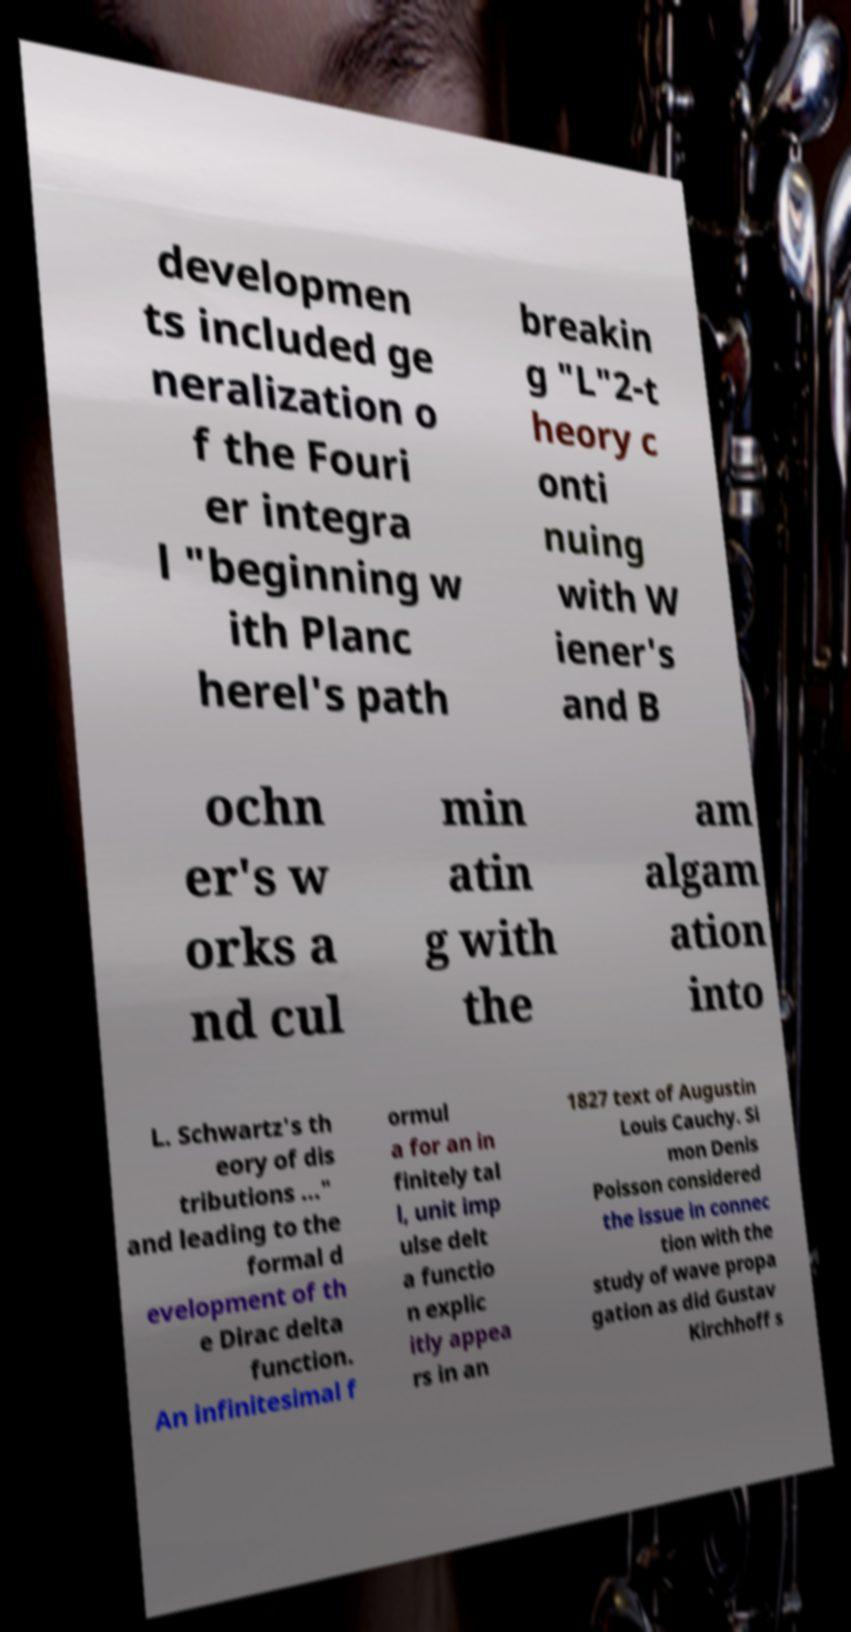Please identify and transcribe the text found in this image. developmen ts included ge neralization o f the Fouri er integra l "beginning w ith Planc herel's path breakin g "L"2-t heory c onti nuing with W iener's and B ochn er's w orks a nd cul min atin g with the am algam ation into L. Schwartz's th eory of dis tributions ..." and leading to the formal d evelopment of th e Dirac delta function. An infinitesimal f ormul a for an in finitely tal l, unit imp ulse delt a functio n explic itly appea rs in an 1827 text of Augustin Louis Cauchy. Si mon Denis Poisson considered the issue in connec tion with the study of wave propa gation as did Gustav Kirchhoff s 